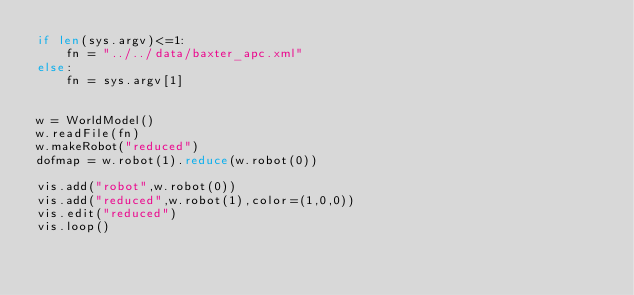<code> <loc_0><loc_0><loc_500><loc_500><_Python_>if len(sys.argv)<=1:
    fn = "../../data/baxter_apc.xml"
else:
    fn = sys.argv[1]


w = WorldModel()
w.readFile(fn)
w.makeRobot("reduced")
dofmap = w.robot(1).reduce(w.robot(0))

vis.add("robot",w.robot(0))
vis.add("reduced",w.robot(1),color=(1,0,0))
vis.edit("reduced")
vis.loop()
</code> 